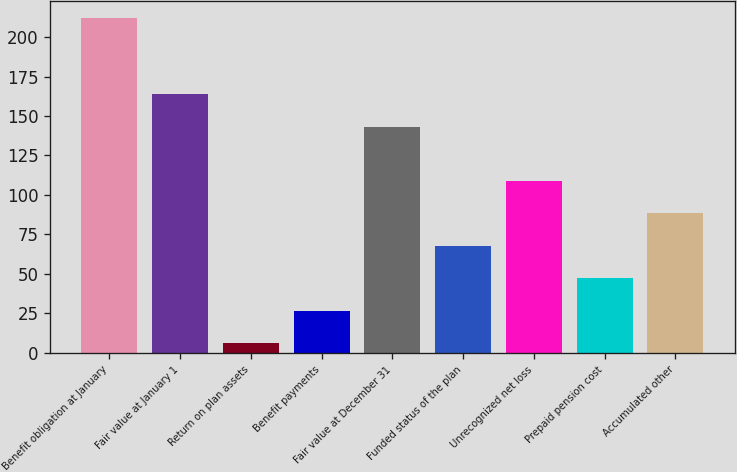<chart> <loc_0><loc_0><loc_500><loc_500><bar_chart><fcel>Benefit obligation at January<fcel>Fair value at January 1<fcel>Return on plan assets<fcel>Benefit payments<fcel>Fair value at December 31<fcel>Funded status of the plan<fcel>Unrecognized net loss<fcel>Prepaid pension cost<fcel>Accumulated other<nl><fcel>212<fcel>163.6<fcel>6<fcel>26.6<fcel>143<fcel>67.8<fcel>109<fcel>47.2<fcel>88.4<nl></chart> 